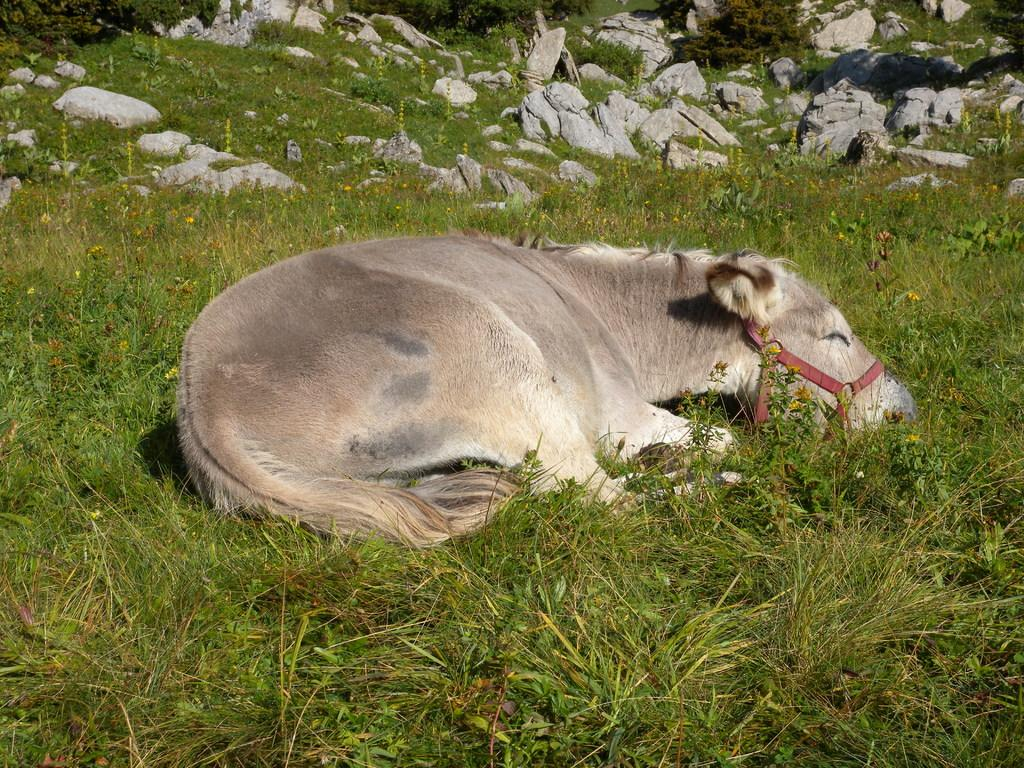What animal can be seen in the image? There is a donkey in the image. What is the donkey doing in the image? The donkey is sleeping on the ground. What is the color of the ground in the image? The ground is in grey color. What type of vegetation is present on the ground? There is grass on the ground. What can be seen in the background of the image? There are stones visible in the background of the image. How many passengers are riding the donkey in the image? There are no passengers riding the donkey in the image; the donkey is sleeping on the ground. What is the shape of the heart-shaped stone in the image? There is no heart-shaped stone present in the image. 